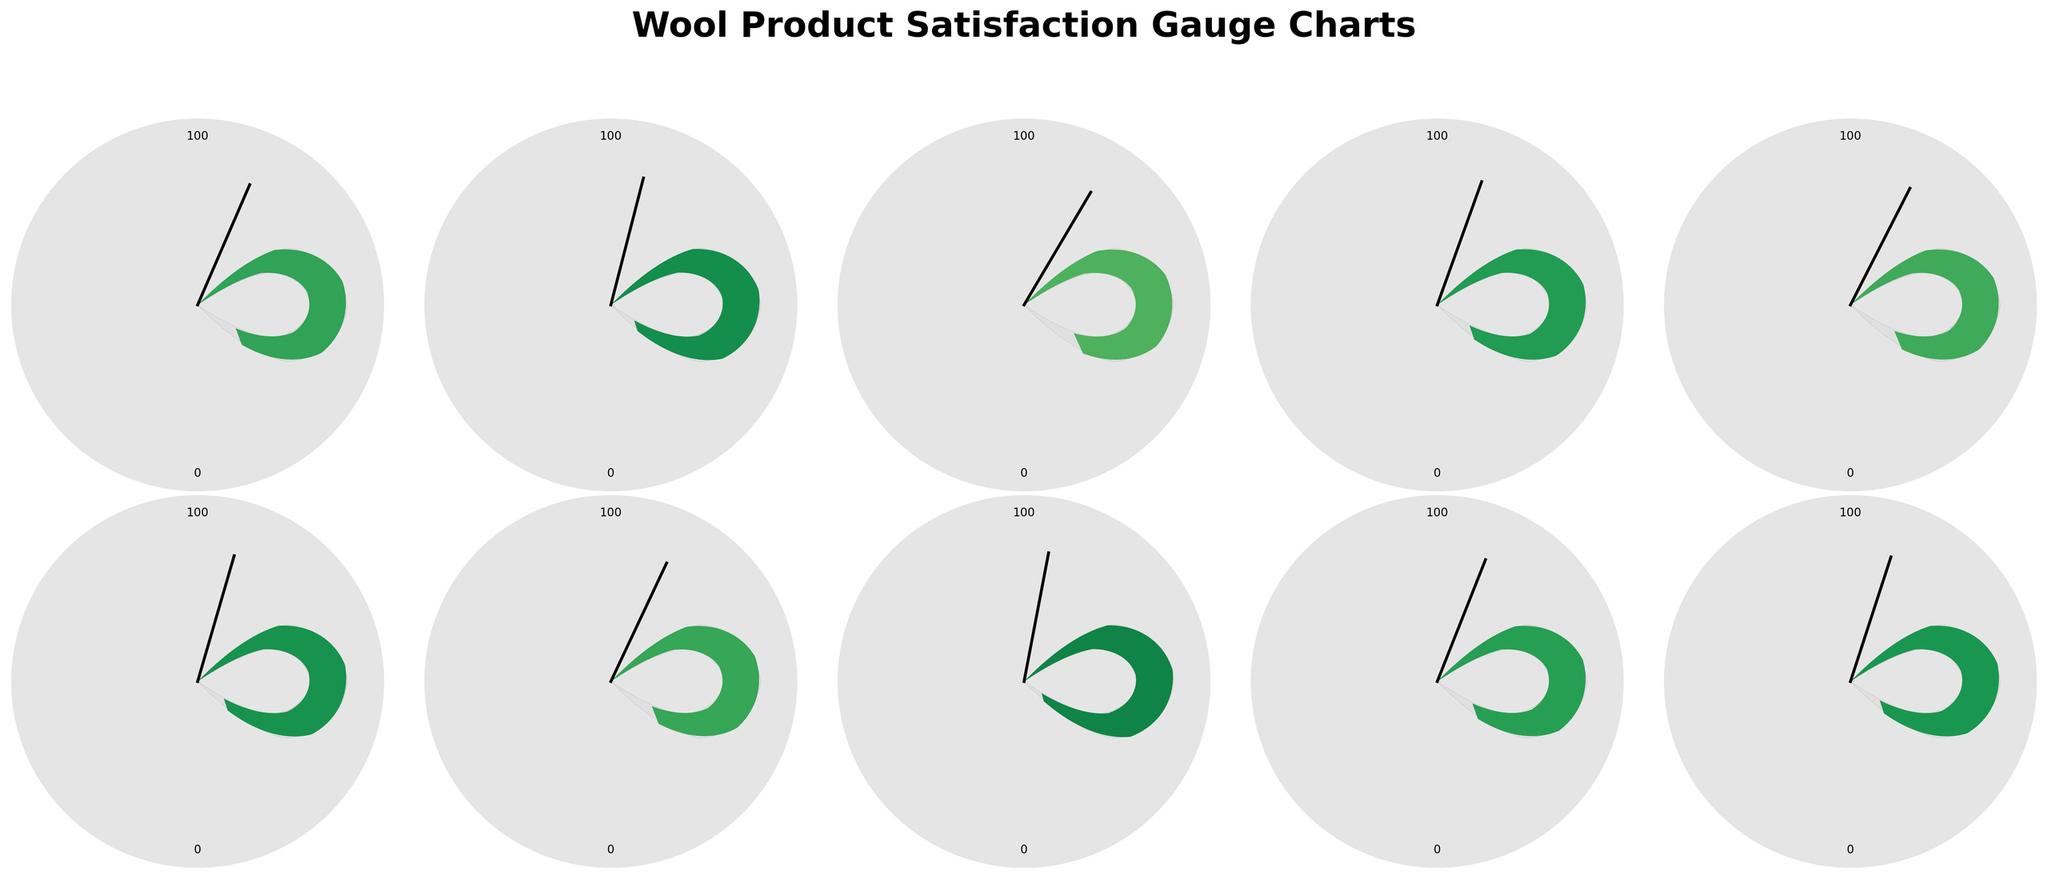What's the title of the figure? The title of the figure is positioned at the top-center and reads "Wool Product Satisfaction Gauge Charts".
Answer: Wool Product Satisfaction Gauge Charts How many products are displayed in the figure? By counting the number of individual gauge charts, we can see there are 10 products displayed.
Answer: 10 Which wool product has the highest customer satisfaction score? From the displayed scores on the gauge charts, the Wool-Silk Blend Shawl has the highest satisfaction score of 94.
Answer: Wool-Silk Blend Shawl Which wool product has the lowest customer satisfaction score? From the displayed scores on the gauge charts, the Lamb's Wool Cardigan has the lowest satisfaction score of 83.
Answer: Lamb's Wool Cardigan What's the average customer satisfaction score for all the products? Sum the scores for all the products: (87 + 92 + 83 + 89 + 85 + 91 + 86 + 94 + 88 + 90) = 885. Divide by the number of products (10). The average satisfaction score is 885 / 10 = 88.5.
Answer: 88.5 Which products have a customer satisfaction score above 90? Examining the gauge charts, the products with scores above 90 are the Cashmere-Wool Blend Scarf (92), Extra-Fine Wool Socks (91), and Wool-Silk Blend Shawl (94).
Answer: Cashmere-Wool Blend Scarf, Extra-Fine Wool Socks, Wool-Silk Blend Shawl What's the range of customer satisfaction scores? The range is the difference between the highest and lowest scores: 94 (highest) - 83 (lowest) = 11.
Answer: 11 How many products have a customer satisfaction score between 85 and 90 inclusive? We need to count the products with scores in this range: Merino Wool Sweater (87), Fine Wool Suit (89), Worsted Wool Dress (85), Boiled Wool Jacket (86), Pure Wool Blanket (88), and Wool Tweed Coat (90). This totals to 6 products.
Answer: 6 What is the median customer satisfaction score for the products? Arrange the scores in ascending order: 83, 85, 86, 87, 88, 89, 90, 91, 92, 94. The median score (middle value) for 10 scores is the average of 5th and 6th scores: (88 + 89) / 2 = 88.5.
Answer: 88.5 